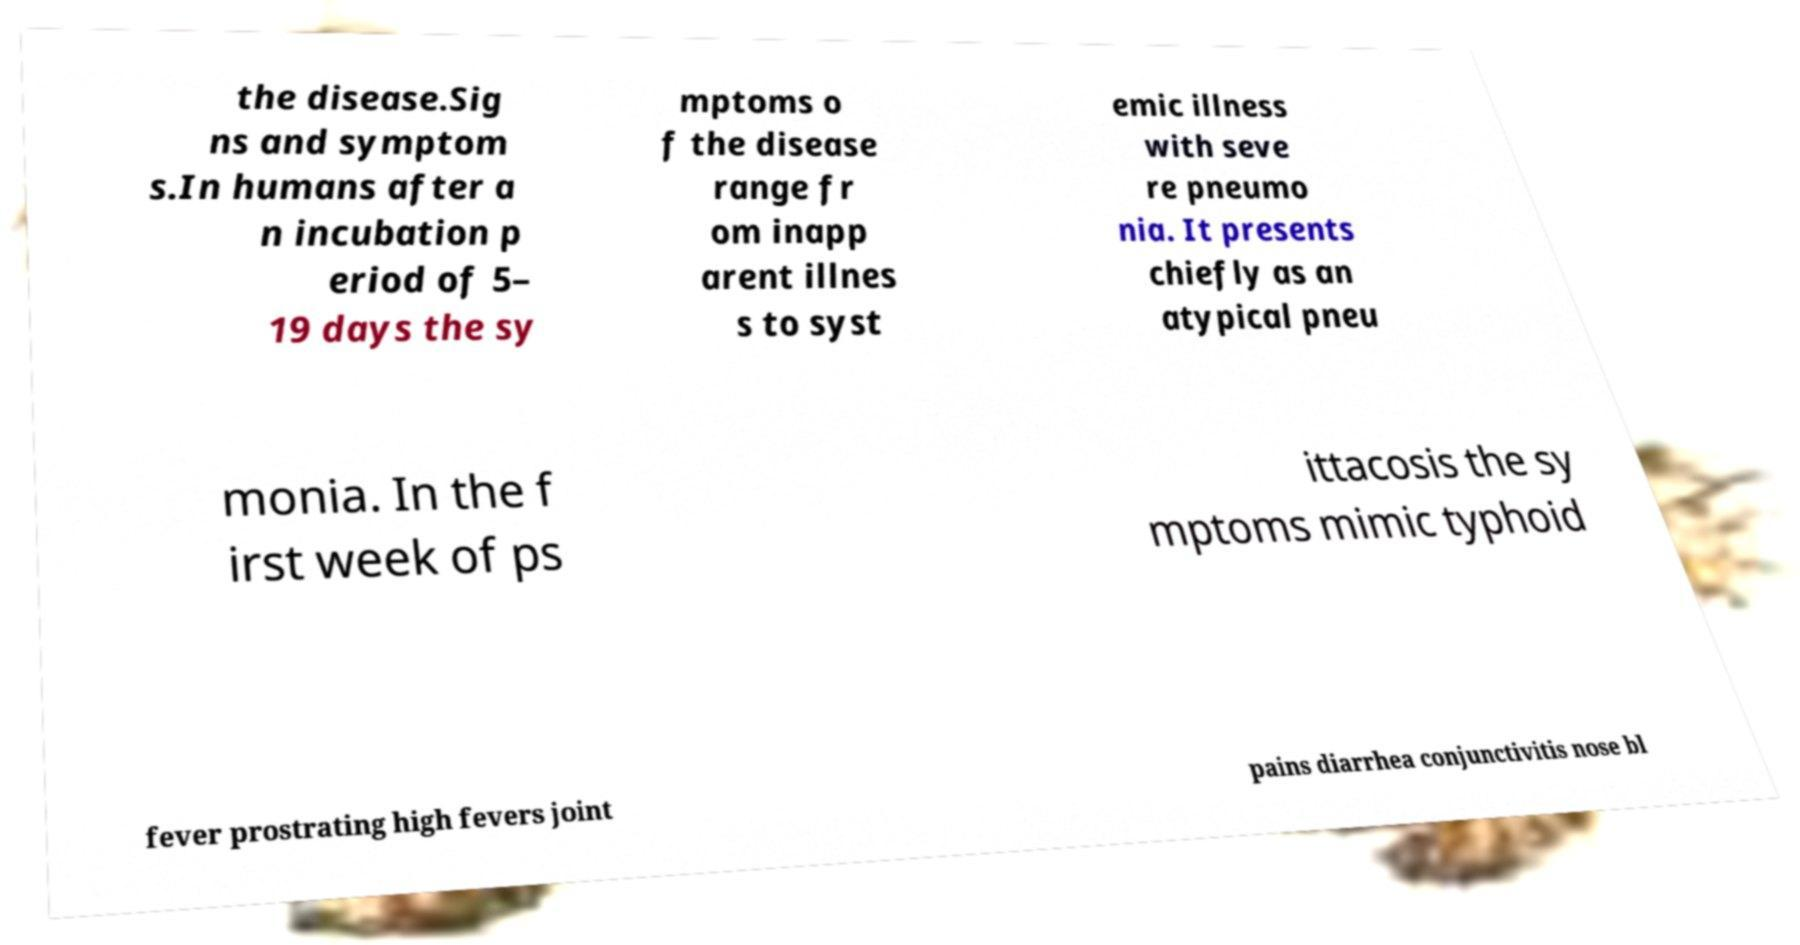Could you assist in decoding the text presented in this image and type it out clearly? the disease.Sig ns and symptom s.In humans after a n incubation p eriod of 5– 19 days the sy mptoms o f the disease range fr om inapp arent illnes s to syst emic illness with seve re pneumo nia. It presents chiefly as an atypical pneu monia. In the f irst week of ps ittacosis the sy mptoms mimic typhoid fever prostrating high fevers joint pains diarrhea conjunctivitis nose bl 